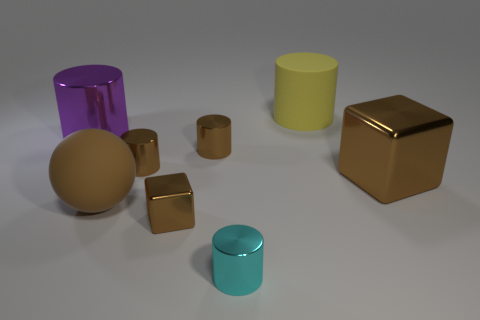Add 1 small cyan metal cylinders. How many objects exist? 9 Subtract all rubber cylinders. How many cylinders are left? 4 Subtract all cylinders. How many objects are left? 3 Subtract 1 balls. How many balls are left? 0 Add 6 small metallic things. How many small metallic things are left? 10 Add 2 big yellow matte things. How many big yellow matte things exist? 3 Subtract all yellow cylinders. How many cylinders are left? 4 Subtract 1 yellow cylinders. How many objects are left? 7 Subtract all green cubes. Subtract all blue spheres. How many cubes are left? 2 Subtract all gray cubes. How many green balls are left? 0 